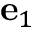Convert formula to latex. <formula><loc_0><loc_0><loc_500><loc_500>e _ { 1 }</formula> 